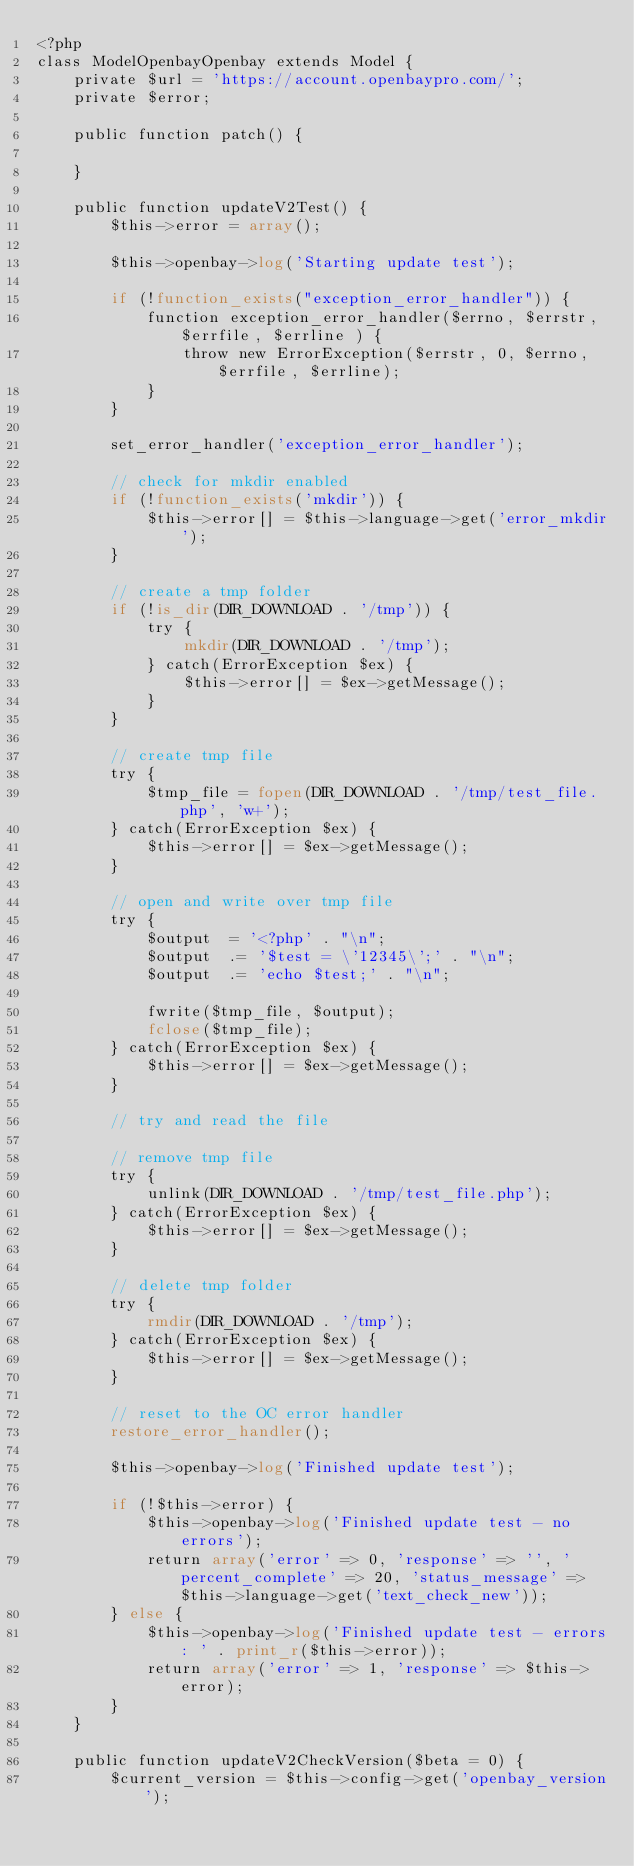Convert code to text. <code><loc_0><loc_0><loc_500><loc_500><_PHP_><?php
class ModelOpenbayOpenbay extends Model {
	private $url = 'https://account.openbaypro.com/';
	private $error;

	public function patch() {

	}

	public function updateV2Test() {
		$this->error = array();

		$this->openbay->log('Starting update test');

		if (!function_exists("exception_error_handler")) {
			function exception_error_handler($errno, $errstr, $errfile, $errline ) {
				throw new ErrorException($errstr, 0, $errno, $errfile, $errline);
			}
		}

		set_error_handler('exception_error_handler');

		// check for mkdir enabled
		if (!function_exists('mkdir')) {
			$this->error[] = $this->language->get('error_mkdir');
		}

		// create a tmp folder
		if (!is_dir(DIR_DOWNLOAD . '/tmp')) {
			try {
				mkdir(DIR_DOWNLOAD . '/tmp');
			} catch(ErrorException $ex) {
				$this->error[] = $ex->getMessage();
			}
		}

		// create tmp file
		try {
			$tmp_file = fopen(DIR_DOWNLOAD . '/tmp/test_file.php', 'w+');
		} catch(ErrorException $ex) {
			$this->error[] = $ex->getMessage();
		}

		// open and write over tmp file
		try {
			$output  = '<?php' . "\n";
			$output  .= '$test = \'12345\';' . "\n";
			$output  .= 'echo $test;' . "\n";

			fwrite($tmp_file, $output);
			fclose($tmp_file);
		} catch(ErrorException $ex) {
			$this->error[] = $ex->getMessage();
		}

		// try and read the file

		// remove tmp file
		try {
			unlink(DIR_DOWNLOAD . '/tmp/test_file.php');
		} catch(ErrorException $ex) {
			$this->error[] = $ex->getMessage();
		}

		// delete tmp folder
		try {
			rmdir(DIR_DOWNLOAD . '/tmp');
		} catch(ErrorException $ex) {
			$this->error[] = $ex->getMessage();
		}

		// reset to the OC error handler
		restore_error_handler();

		$this->openbay->log('Finished update test');

		if (!$this->error) {
			$this->openbay->log('Finished update test - no errors');
			return array('error' => 0, 'response' => '', 'percent_complete' => 20, 'status_message' => $this->language->get('text_check_new'));
		} else {
			$this->openbay->log('Finished update test - errors: ' . print_r($this->error));
			return array('error' => 1, 'response' => $this->error);
		}
	}

	public function updateV2CheckVersion($beta = 0) {
		$current_version = $this->config->get('openbay_version');
</code> 